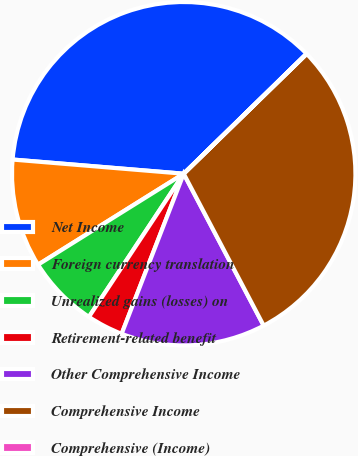Convert chart. <chart><loc_0><loc_0><loc_500><loc_500><pie_chart><fcel>Net Income<fcel>Foreign currency translation<fcel>Unrealized gains (losses) on<fcel>Retirement-related benefit<fcel>Other Comprehensive Income<fcel>Comprehensive Income<fcel>Comprehensive (Income)<nl><fcel>36.37%<fcel>10.2%<fcel>6.81%<fcel>3.42%<fcel>13.6%<fcel>29.58%<fcel>0.03%<nl></chart> 